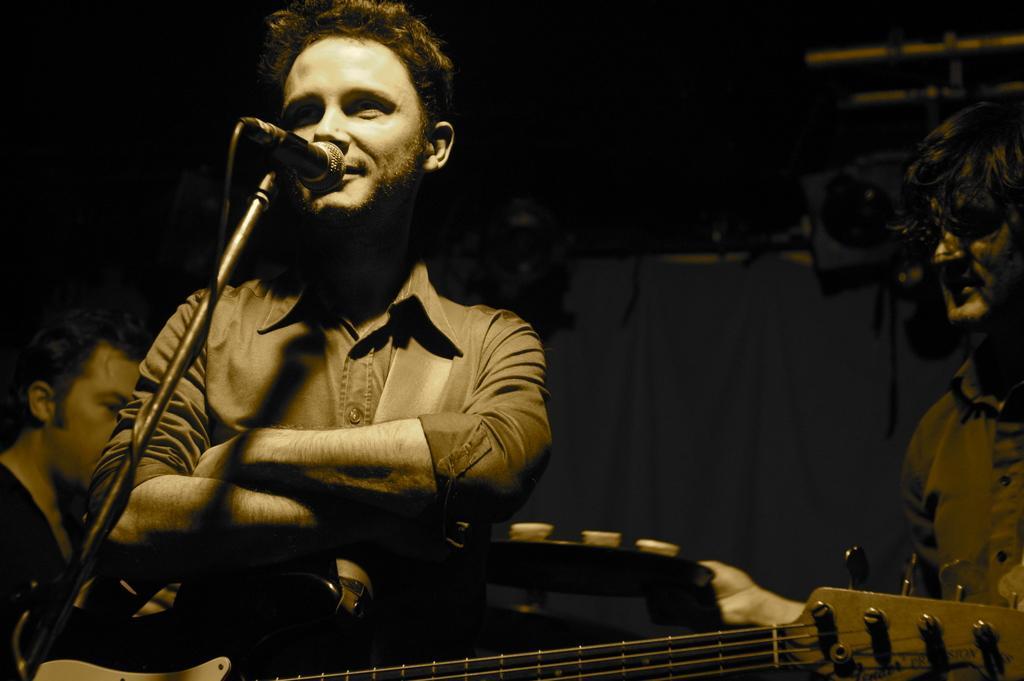Please provide a concise description of this image. In this picture there is a man singing and there is a guitar and onto the right does a person standing on the left is a person sitting 